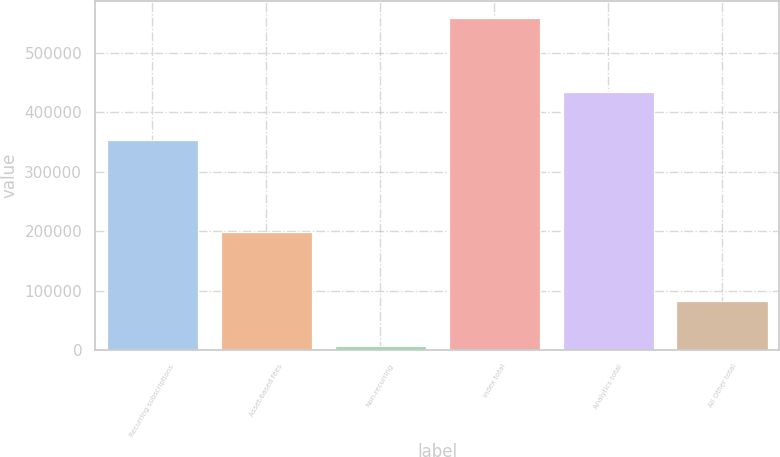Convert chart to OTSL. <chart><loc_0><loc_0><loc_500><loc_500><bar_chart><fcel>Recurring subscriptions<fcel>Asset-based fees<fcel>Non-recurring<fcel>Index total<fcel>Analytics total<fcel>All Other total<nl><fcel>353136<fcel>197974<fcel>7854<fcel>558964<fcel>433424<fcel>82625<nl></chart> 